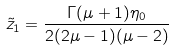Convert formula to latex. <formula><loc_0><loc_0><loc_500><loc_500>\tilde { z } _ { 1 } = \frac { \Gamma ( \mu + 1 ) \eta _ { 0 } } { 2 ( 2 \mu - 1 ) ( \mu - 2 ) }</formula> 